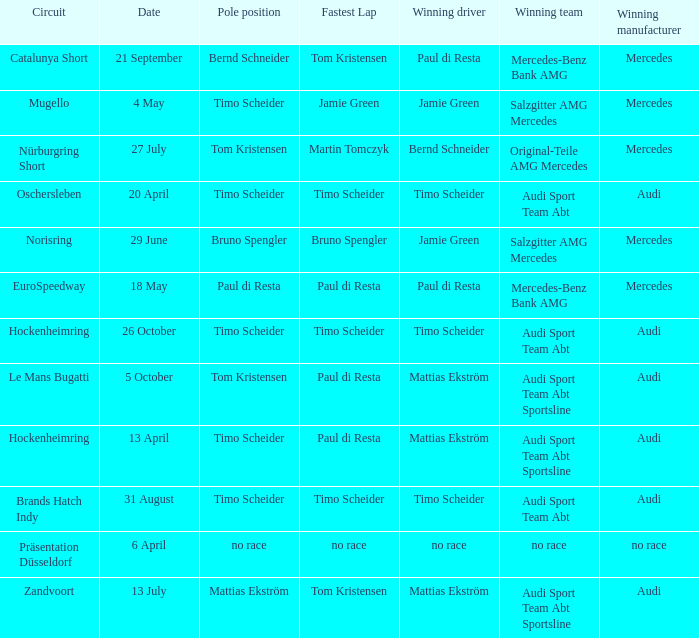What is the fastest lap in the Le Mans Bugatti circuit? Paul di Resta. Parse the full table. {'header': ['Circuit', 'Date', 'Pole position', 'Fastest Lap', 'Winning driver', 'Winning team', 'Winning manufacturer'], 'rows': [['Catalunya Short', '21 September', 'Bernd Schneider', 'Tom Kristensen', 'Paul di Resta', 'Mercedes-Benz Bank AMG', 'Mercedes'], ['Mugello', '4 May', 'Timo Scheider', 'Jamie Green', 'Jamie Green', 'Salzgitter AMG Mercedes', 'Mercedes'], ['Nürburgring Short', '27 July', 'Tom Kristensen', 'Martin Tomczyk', 'Bernd Schneider', 'Original-Teile AMG Mercedes', 'Mercedes'], ['Oschersleben', '20 April', 'Timo Scheider', 'Timo Scheider', 'Timo Scheider', 'Audi Sport Team Abt', 'Audi'], ['Norisring', '29 June', 'Bruno Spengler', 'Bruno Spengler', 'Jamie Green', 'Salzgitter AMG Mercedes', 'Mercedes'], ['EuroSpeedway', '18 May', 'Paul di Resta', 'Paul di Resta', 'Paul di Resta', 'Mercedes-Benz Bank AMG', 'Mercedes'], ['Hockenheimring', '26 October', 'Timo Scheider', 'Timo Scheider', 'Timo Scheider', 'Audi Sport Team Abt', 'Audi'], ['Le Mans Bugatti', '5 October', 'Tom Kristensen', 'Paul di Resta', 'Mattias Ekström', 'Audi Sport Team Abt Sportsline', 'Audi'], ['Hockenheimring', '13 April', 'Timo Scheider', 'Paul di Resta', 'Mattias Ekström', 'Audi Sport Team Abt Sportsline', 'Audi'], ['Brands Hatch Indy', '31 August', 'Timo Scheider', 'Timo Scheider', 'Timo Scheider', 'Audi Sport Team Abt', 'Audi'], ['Präsentation Düsseldorf', '6 April', 'no race', 'no race', 'no race', 'no race', 'no race'], ['Zandvoort', '13 July', 'Mattias Ekström', 'Tom Kristensen', 'Mattias Ekström', 'Audi Sport Team Abt Sportsline', 'Audi']]} 